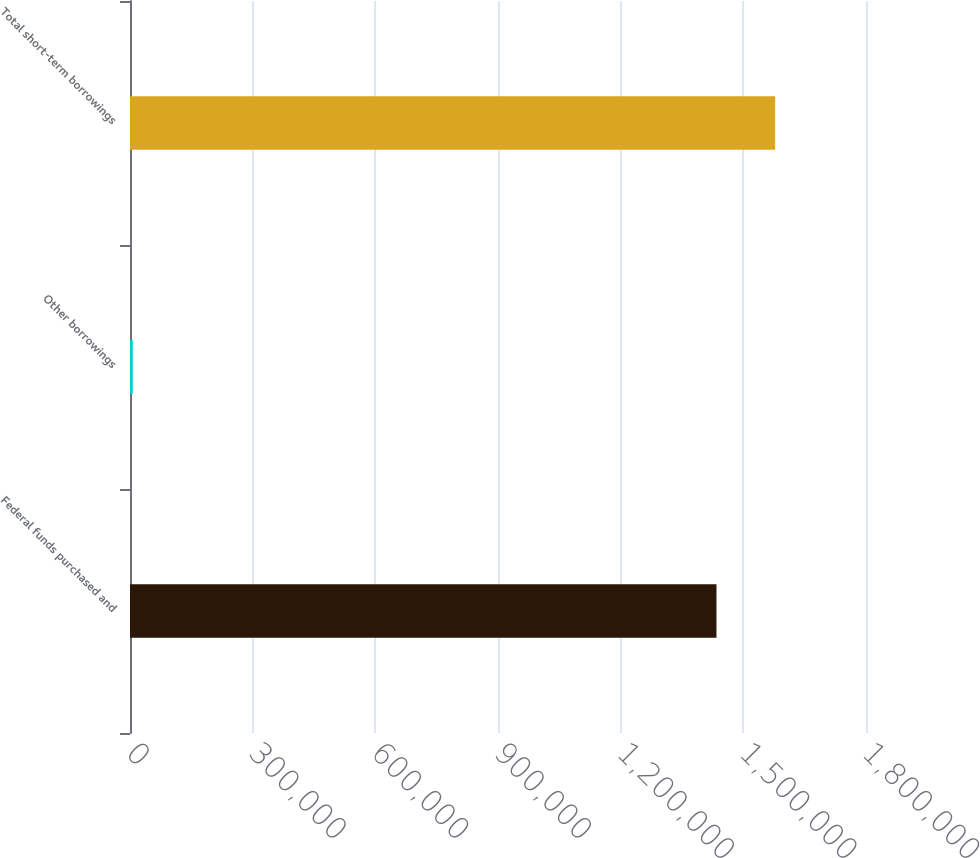Convert chart. <chart><loc_0><loc_0><loc_500><loc_500><bar_chart><fcel>Federal funds purchased and<fcel>Other borrowings<fcel>Total short-term borrowings<nl><fcel>1.43431e+06<fcel>6782<fcel>1.57774e+06<nl></chart> 